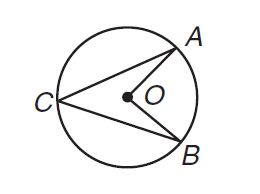Answer the mathemtical geometry problem and directly provide the correct option letter.
Question: What is the ratio of the measure of \angle A C B to the measure of \angle A O B?
Choices: A: 0.5 B: 1 C: 2 D: not enough information A 